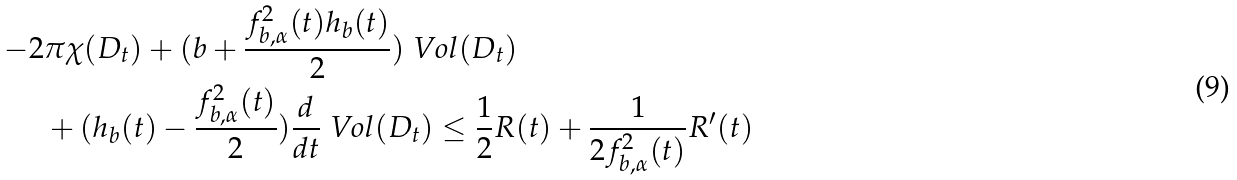Convert formula to latex. <formula><loc_0><loc_0><loc_500><loc_500>- 2 & \pi \chi ( D _ { t } ) + ( b + \frac { f _ { b , \alpha } ^ { 2 } ( t ) h _ { b } ( t ) } { 2 } ) \ V o l ( D _ { t } ) \\ & + ( h _ { b } ( t ) - \frac { f _ { b , \alpha } ^ { 2 } ( t ) } { 2 } ) \frac { d } { d t } \ V o l ( D _ { t } ) \leq \frac { 1 } { 2 } R ( t ) + \frac { 1 } { 2 f _ { b , \alpha } ^ { 2 } ( t ) } R ^ { \prime } ( t )</formula> 